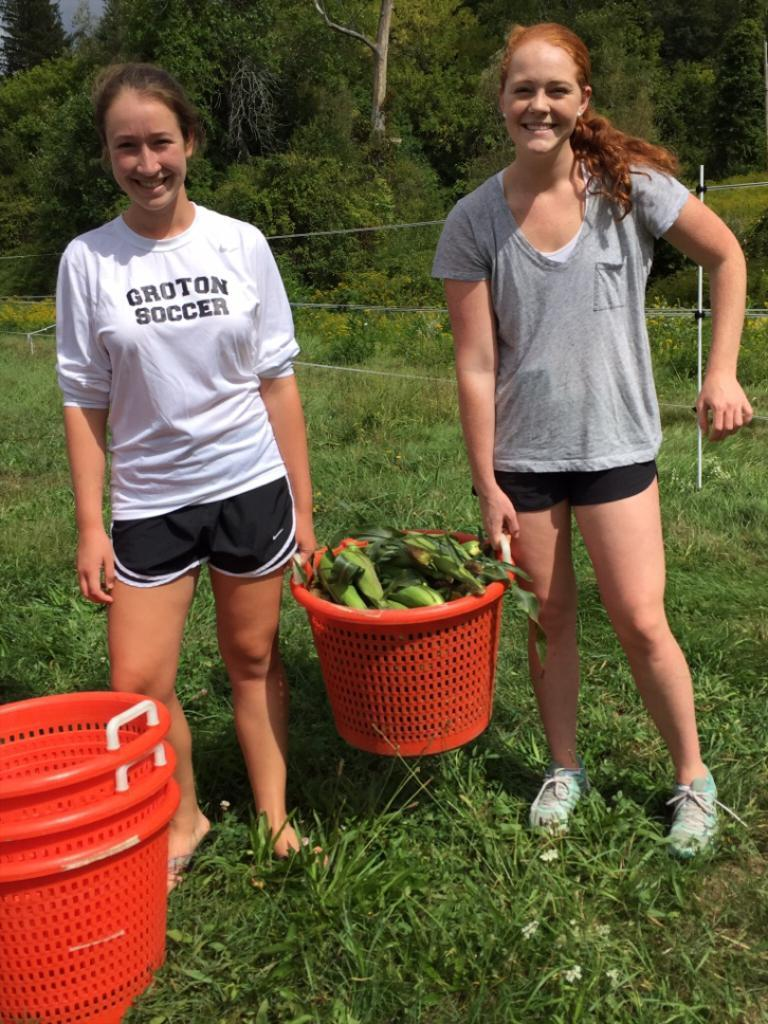<image>
Offer a succinct explanation of the picture presented. A woman wearing a Groton Soccer shirt holds a basket full of corn alongside another woman. 